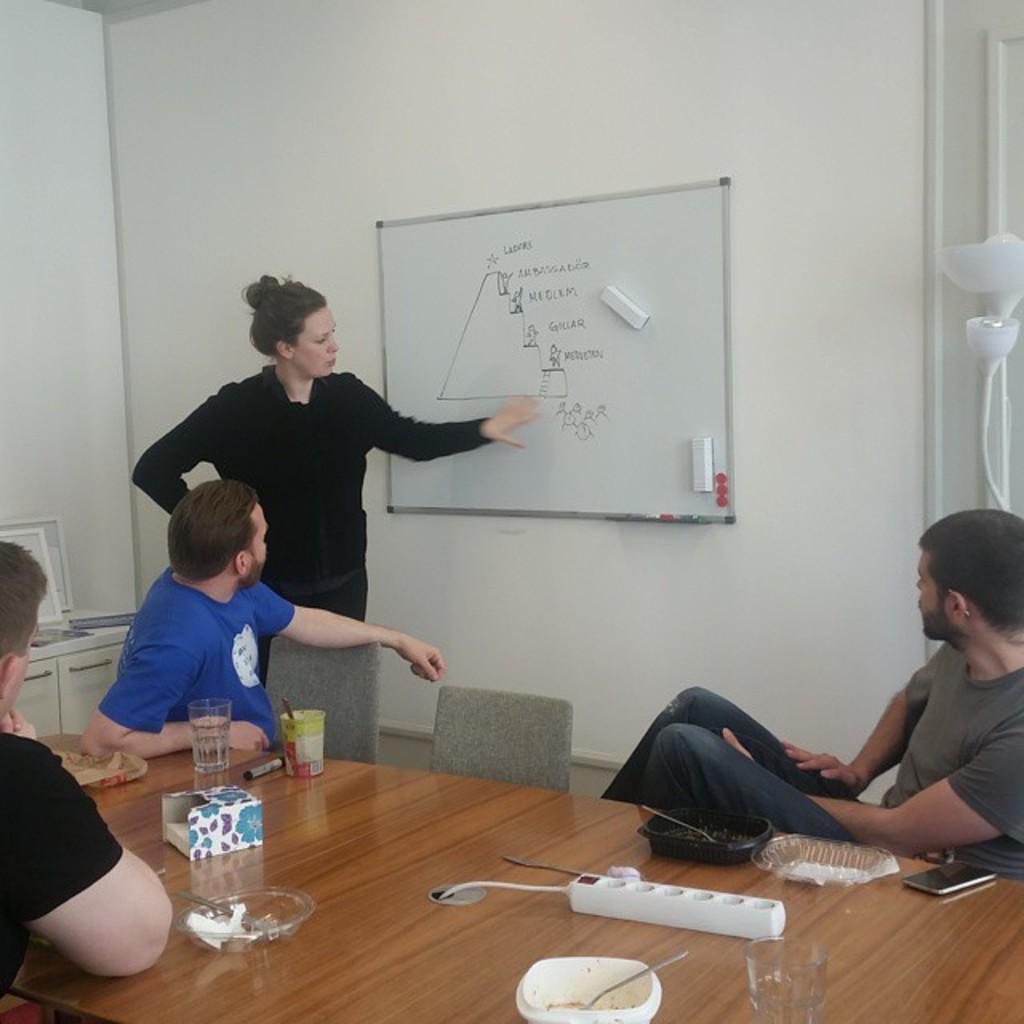Please provide a concise description of this image. In this image I can see four people. Among them three people are sitting in front of the table. On the table there are bowls,spoons and glasses. And one person is standing to the side of the board. 